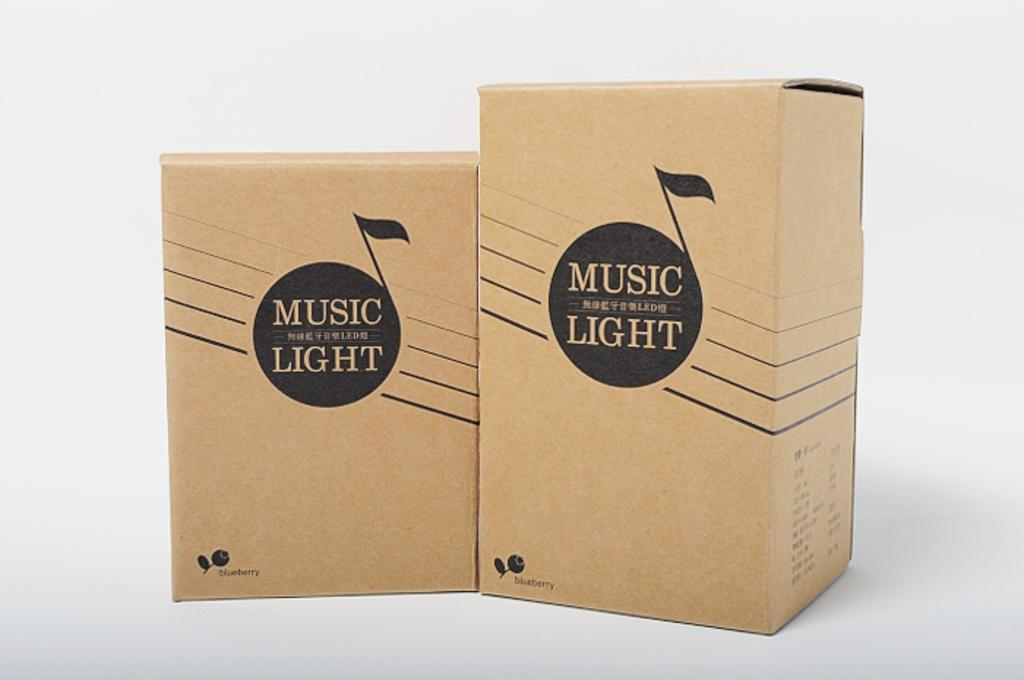<image>
Write a terse but informative summary of the picture. Two cardboard boxes with MUSIC LIGHT labels stand adjacent to each other. 